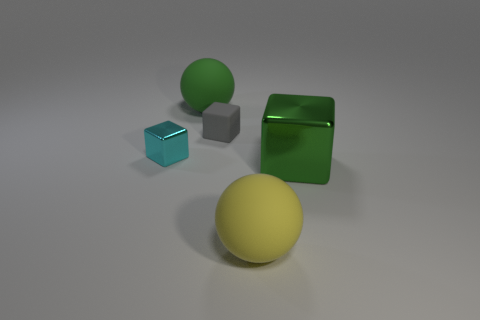Subtract 1 blocks. How many blocks are left? 2 Subtract all small cubes. How many cubes are left? 1 Add 2 tiny matte things. How many objects exist? 7 Subtract all blocks. How many objects are left? 2 Add 5 small matte objects. How many small matte objects exist? 6 Subtract 0 blue spheres. How many objects are left? 5 Subtract all big red rubber cylinders. Subtract all blocks. How many objects are left? 2 Add 5 big shiny things. How many big shiny things are left? 6 